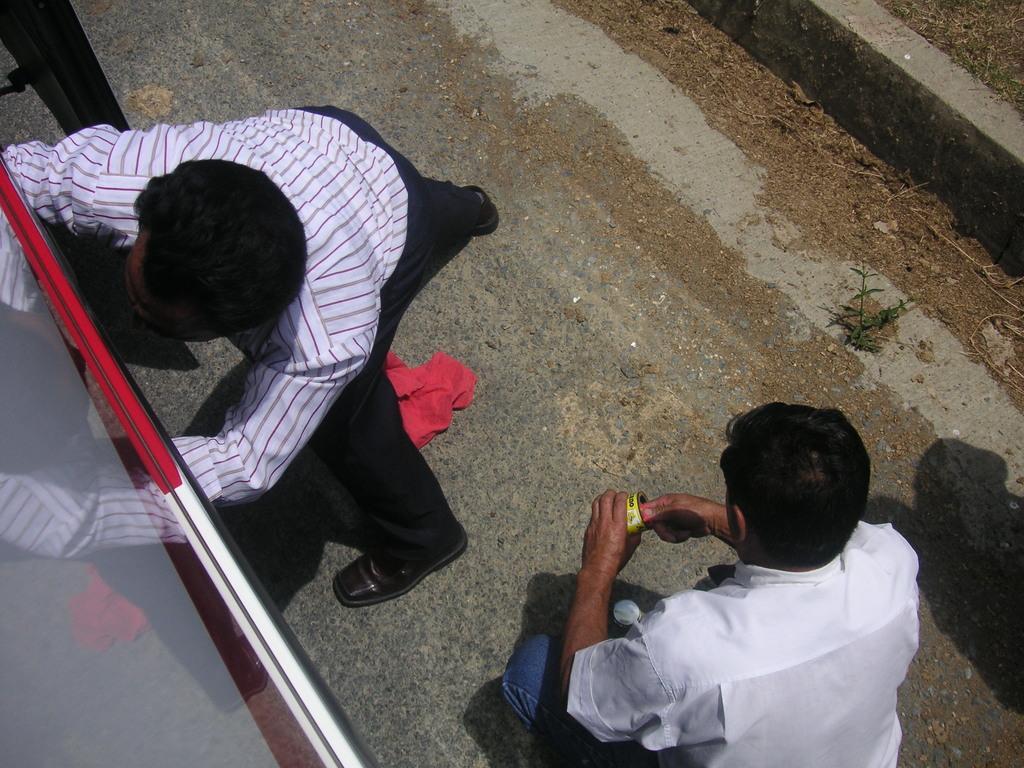In one or two sentences, can you explain what this image depicts? This picture is clicked outside. On the right we can see a person holding some object and squatting on the ground. On the left we can see another person seems to be standing on the ground. In the left corner we can see an object and the glass. In the background we can see the ground and some other items. 